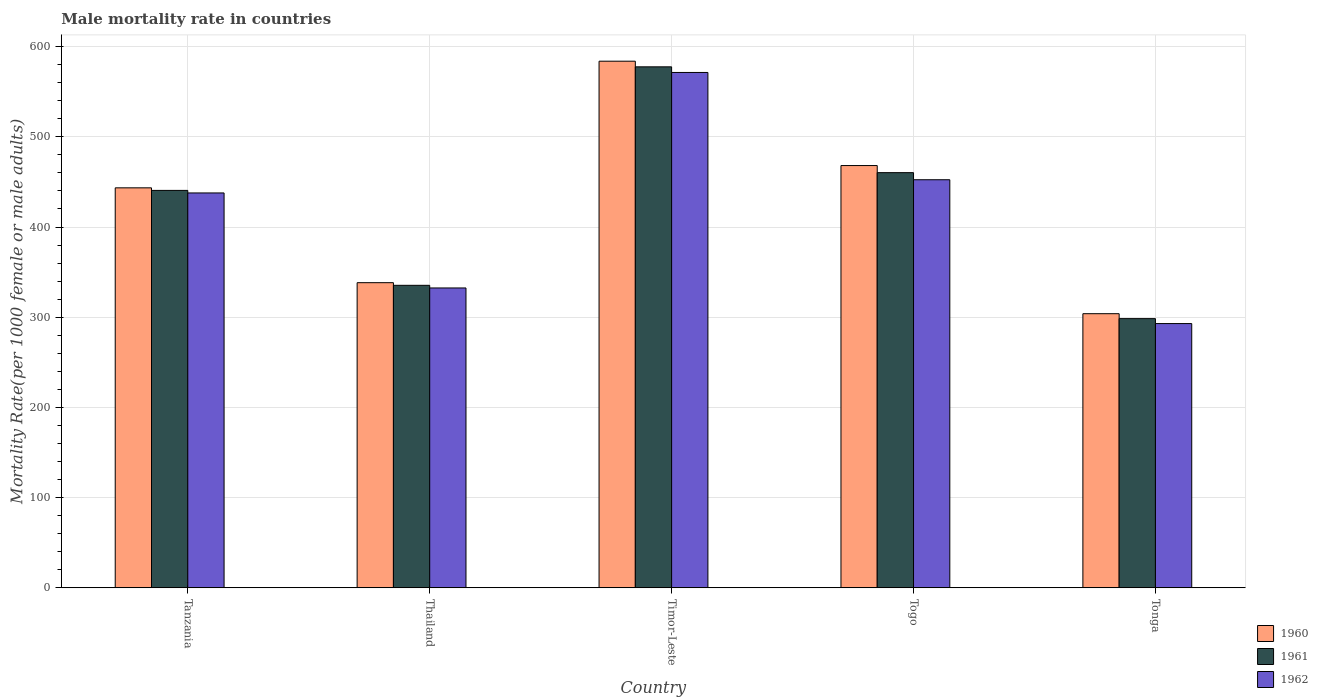How many bars are there on the 1st tick from the left?
Make the answer very short. 3. How many bars are there on the 1st tick from the right?
Your answer should be very brief. 3. What is the label of the 4th group of bars from the left?
Ensure brevity in your answer.  Togo. In how many cases, is the number of bars for a given country not equal to the number of legend labels?
Make the answer very short. 0. What is the male mortality rate in 1962 in Tonga?
Offer a terse response. 292.94. Across all countries, what is the maximum male mortality rate in 1961?
Provide a short and direct response. 577.61. Across all countries, what is the minimum male mortality rate in 1961?
Make the answer very short. 298.41. In which country was the male mortality rate in 1961 maximum?
Your response must be concise. Timor-Leste. In which country was the male mortality rate in 1962 minimum?
Keep it short and to the point. Tonga. What is the total male mortality rate in 1960 in the graph?
Give a very brief answer. 2137.6. What is the difference between the male mortality rate in 1962 in Togo and that in Tonga?
Offer a terse response. 159.48. What is the difference between the male mortality rate in 1962 in Thailand and the male mortality rate in 1960 in Timor-Leste?
Keep it short and to the point. -251.43. What is the average male mortality rate in 1960 per country?
Your answer should be very brief. 427.52. What is the difference between the male mortality rate of/in 1961 and male mortality rate of/in 1962 in Timor-Leste?
Offer a terse response. 6.24. In how many countries, is the male mortality rate in 1960 greater than 380?
Your response must be concise. 3. What is the ratio of the male mortality rate in 1961 in Thailand to that in Togo?
Give a very brief answer. 0.73. Is the male mortality rate in 1961 in Tanzania less than that in Tonga?
Offer a terse response. No. Is the difference between the male mortality rate in 1961 in Tanzania and Tonga greater than the difference between the male mortality rate in 1962 in Tanzania and Tonga?
Give a very brief answer. No. What is the difference between the highest and the second highest male mortality rate in 1961?
Give a very brief answer. -137.01. What is the difference between the highest and the lowest male mortality rate in 1960?
Your response must be concise. 279.97. In how many countries, is the male mortality rate in 1962 greater than the average male mortality rate in 1962 taken over all countries?
Make the answer very short. 3. Is the sum of the male mortality rate in 1961 in Tanzania and Thailand greater than the maximum male mortality rate in 1962 across all countries?
Give a very brief answer. Yes. What does the 1st bar from the right in Thailand represents?
Keep it short and to the point. 1962. Is it the case that in every country, the sum of the male mortality rate in 1962 and male mortality rate in 1961 is greater than the male mortality rate in 1960?
Provide a succinct answer. Yes. How many countries are there in the graph?
Your answer should be very brief. 5. What is the difference between two consecutive major ticks on the Y-axis?
Provide a succinct answer. 100. Are the values on the major ticks of Y-axis written in scientific E-notation?
Ensure brevity in your answer.  No. How are the legend labels stacked?
Your response must be concise. Vertical. What is the title of the graph?
Provide a succinct answer. Male mortality rate in countries. Does "1987" appear as one of the legend labels in the graph?
Make the answer very short. No. What is the label or title of the Y-axis?
Offer a very short reply. Mortality Rate(per 1000 female or male adults). What is the Mortality Rate(per 1000 female or male adults) in 1960 in Tanzania?
Offer a very short reply. 443.44. What is the Mortality Rate(per 1000 female or male adults) of 1961 in Tanzania?
Provide a succinct answer. 440.6. What is the Mortality Rate(per 1000 female or male adults) in 1962 in Tanzania?
Provide a succinct answer. 437.77. What is the Mortality Rate(per 1000 female or male adults) of 1960 in Thailand?
Ensure brevity in your answer.  338.28. What is the Mortality Rate(per 1000 female or male adults) in 1961 in Thailand?
Keep it short and to the point. 335.35. What is the Mortality Rate(per 1000 female or male adults) of 1962 in Thailand?
Give a very brief answer. 332.42. What is the Mortality Rate(per 1000 female or male adults) of 1960 in Timor-Leste?
Provide a succinct answer. 583.85. What is the Mortality Rate(per 1000 female or male adults) of 1961 in Timor-Leste?
Keep it short and to the point. 577.61. What is the Mortality Rate(per 1000 female or male adults) in 1962 in Timor-Leste?
Make the answer very short. 571.37. What is the Mortality Rate(per 1000 female or male adults) in 1960 in Togo?
Your response must be concise. 468.15. What is the Mortality Rate(per 1000 female or male adults) in 1961 in Togo?
Your answer should be compact. 460.29. What is the Mortality Rate(per 1000 female or male adults) of 1962 in Togo?
Your response must be concise. 452.42. What is the Mortality Rate(per 1000 female or male adults) in 1960 in Tonga?
Give a very brief answer. 303.88. What is the Mortality Rate(per 1000 female or male adults) of 1961 in Tonga?
Offer a very short reply. 298.41. What is the Mortality Rate(per 1000 female or male adults) of 1962 in Tonga?
Your answer should be very brief. 292.94. Across all countries, what is the maximum Mortality Rate(per 1000 female or male adults) of 1960?
Keep it short and to the point. 583.85. Across all countries, what is the maximum Mortality Rate(per 1000 female or male adults) in 1961?
Your answer should be compact. 577.61. Across all countries, what is the maximum Mortality Rate(per 1000 female or male adults) of 1962?
Keep it short and to the point. 571.37. Across all countries, what is the minimum Mortality Rate(per 1000 female or male adults) in 1960?
Offer a terse response. 303.88. Across all countries, what is the minimum Mortality Rate(per 1000 female or male adults) in 1961?
Your response must be concise. 298.41. Across all countries, what is the minimum Mortality Rate(per 1000 female or male adults) of 1962?
Make the answer very short. 292.94. What is the total Mortality Rate(per 1000 female or male adults) in 1960 in the graph?
Provide a short and direct response. 2137.6. What is the total Mortality Rate(per 1000 female or male adults) of 1961 in the graph?
Keep it short and to the point. 2112.26. What is the total Mortality Rate(per 1000 female or male adults) in 1962 in the graph?
Your answer should be very brief. 2086.92. What is the difference between the Mortality Rate(per 1000 female or male adults) of 1960 in Tanzania and that in Thailand?
Ensure brevity in your answer.  105.15. What is the difference between the Mortality Rate(per 1000 female or male adults) in 1961 in Tanzania and that in Thailand?
Your answer should be very brief. 105.25. What is the difference between the Mortality Rate(per 1000 female or male adults) in 1962 in Tanzania and that in Thailand?
Keep it short and to the point. 105.34. What is the difference between the Mortality Rate(per 1000 female or male adults) in 1960 in Tanzania and that in Timor-Leste?
Offer a very short reply. -140.41. What is the difference between the Mortality Rate(per 1000 female or male adults) in 1961 in Tanzania and that in Timor-Leste?
Your answer should be compact. -137.01. What is the difference between the Mortality Rate(per 1000 female or male adults) of 1962 in Tanzania and that in Timor-Leste?
Ensure brevity in your answer.  -133.6. What is the difference between the Mortality Rate(per 1000 female or male adults) in 1960 in Tanzania and that in Togo?
Ensure brevity in your answer.  -24.71. What is the difference between the Mortality Rate(per 1000 female or male adults) in 1961 in Tanzania and that in Togo?
Your answer should be compact. -19.68. What is the difference between the Mortality Rate(per 1000 female or male adults) in 1962 in Tanzania and that in Togo?
Your response must be concise. -14.65. What is the difference between the Mortality Rate(per 1000 female or male adults) in 1960 in Tanzania and that in Tonga?
Your answer should be very brief. 139.56. What is the difference between the Mortality Rate(per 1000 female or male adults) in 1961 in Tanzania and that in Tonga?
Keep it short and to the point. 142.19. What is the difference between the Mortality Rate(per 1000 female or male adults) of 1962 in Tanzania and that in Tonga?
Your response must be concise. 144.83. What is the difference between the Mortality Rate(per 1000 female or male adults) of 1960 in Thailand and that in Timor-Leste?
Provide a succinct answer. -245.57. What is the difference between the Mortality Rate(per 1000 female or male adults) in 1961 in Thailand and that in Timor-Leste?
Your response must be concise. -242.26. What is the difference between the Mortality Rate(per 1000 female or male adults) in 1962 in Thailand and that in Timor-Leste?
Offer a very short reply. -238.95. What is the difference between the Mortality Rate(per 1000 female or male adults) in 1960 in Thailand and that in Togo?
Ensure brevity in your answer.  -129.87. What is the difference between the Mortality Rate(per 1000 female or male adults) in 1961 in Thailand and that in Togo?
Provide a short and direct response. -124.93. What is the difference between the Mortality Rate(per 1000 female or male adults) in 1962 in Thailand and that in Togo?
Ensure brevity in your answer.  -120. What is the difference between the Mortality Rate(per 1000 female or male adults) of 1960 in Thailand and that in Tonga?
Your answer should be very brief. 34.4. What is the difference between the Mortality Rate(per 1000 female or male adults) of 1961 in Thailand and that in Tonga?
Provide a succinct answer. 36.94. What is the difference between the Mortality Rate(per 1000 female or male adults) of 1962 in Thailand and that in Tonga?
Give a very brief answer. 39.48. What is the difference between the Mortality Rate(per 1000 female or male adults) of 1960 in Timor-Leste and that in Togo?
Your response must be concise. 115.7. What is the difference between the Mortality Rate(per 1000 female or male adults) in 1961 in Timor-Leste and that in Togo?
Offer a very short reply. 117.33. What is the difference between the Mortality Rate(per 1000 female or male adults) of 1962 in Timor-Leste and that in Togo?
Give a very brief answer. 118.95. What is the difference between the Mortality Rate(per 1000 female or male adults) in 1960 in Timor-Leste and that in Tonga?
Your response must be concise. 279.97. What is the difference between the Mortality Rate(per 1000 female or male adults) of 1961 in Timor-Leste and that in Tonga?
Your answer should be very brief. 279.2. What is the difference between the Mortality Rate(per 1000 female or male adults) in 1962 in Timor-Leste and that in Tonga?
Give a very brief answer. 278.43. What is the difference between the Mortality Rate(per 1000 female or male adults) in 1960 in Togo and that in Tonga?
Your response must be concise. 164.27. What is the difference between the Mortality Rate(per 1000 female or male adults) of 1961 in Togo and that in Tonga?
Your response must be concise. 161.88. What is the difference between the Mortality Rate(per 1000 female or male adults) in 1962 in Togo and that in Tonga?
Your response must be concise. 159.48. What is the difference between the Mortality Rate(per 1000 female or male adults) of 1960 in Tanzania and the Mortality Rate(per 1000 female or male adults) of 1961 in Thailand?
Your response must be concise. 108.08. What is the difference between the Mortality Rate(per 1000 female or male adults) in 1960 in Tanzania and the Mortality Rate(per 1000 female or male adults) in 1962 in Thailand?
Offer a very short reply. 111.01. What is the difference between the Mortality Rate(per 1000 female or male adults) in 1961 in Tanzania and the Mortality Rate(per 1000 female or male adults) in 1962 in Thailand?
Your answer should be very brief. 108.18. What is the difference between the Mortality Rate(per 1000 female or male adults) of 1960 in Tanzania and the Mortality Rate(per 1000 female or male adults) of 1961 in Timor-Leste?
Provide a short and direct response. -134.17. What is the difference between the Mortality Rate(per 1000 female or male adults) in 1960 in Tanzania and the Mortality Rate(per 1000 female or male adults) in 1962 in Timor-Leste?
Ensure brevity in your answer.  -127.93. What is the difference between the Mortality Rate(per 1000 female or male adults) in 1961 in Tanzania and the Mortality Rate(per 1000 female or male adults) in 1962 in Timor-Leste?
Your answer should be compact. -130.77. What is the difference between the Mortality Rate(per 1000 female or male adults) in 1960 in Tanzania and the Mortality Rate(per 1000 female or male adults) in 1961 in Togo?
Make the answer very short. -16.85. What is the difference between the Mortality Rate(per 1000 female or male adults) of 1960 in Tanzania and the Mortality Rate(per 1000 female or male adults) of 1962 in Togo?
Ensure brevity in your answer.  -8.98. What is the difference between the Mortality Rate(per 1000 female or male adults) of 1961 in Tanzania and the Mortality Rate(per 1000 female or male adults) of 1962 in Togo?
Make the answer very short. -11.82. What is the difference between the Mortality Rate(per 1000 female or male adults) of 1960 in Tanzania and the Mortality Rate(per 1000 female or male adults) of 1961 in Tonga?
Give a very brief answer. 145.03. What is the difference between the Mortality Rate(per 1000 female or male adults) of 1960 in Tanzania and the Mortality Rate(per 1000 female or male adults) of 1962 in Tonga?
Ensure brevity in your answer.  150.5. What is the difference between the Mortality Rate(per 1000 female or male adults) in 1961 in Tanzania and the Mortality Rate(per 1000 female or male adults) in 1962 in Tonga?
Offer a terse response. 147.66. What is the difference between the Mortality Rate(per 1000 female or male adults) of 1960 in Thailand and the Mortality Rate(per 1000 female or male adults) of 1961 in Timor-Leste?
Offer a terse response. -239.33. What is the difference between the Mortality Rate(per 1000 female or male adults) in 1960 in Thailand and the Mortality Rate(per 1000 female or male adults) in 1962 in Timor-Leste?
Your answer should be compact. -233.09. What is the difference between the Mortality Rate(per 1000 female or male adults) of 1961 in Thailand and the Mortality Rate(per 1000 female or male adults) of 1962 in Timor-Leste?
Offer a very short reply. -236.02. What is the difference between the Mortality Rate(per 1000 female or male adults) of 1960 in Thailand and the Mortality Rate(per 1000 female or male adults) of 1961 in Togo?
Keep it short and to the point. -122. What is the difference between the Mortality Rate(per 1000 female or male adults) in 1960 in Thailand and the Mortality Rate(per 1000 female or male adults) in 1962 in Togo?
Your response must be concise. -114.14. What is the difference between the Mortality Rate(per 1000 female or male adults) in 1961 in Thailand and the Mortality Rate(per 1000 female or male adults) in 1962 in Togo?
Offer a very short reply. -117.06. What is the difference between the Mortality Rate(per 1000 female or male adults) of 1960 in Thailand and the Mortality Rate(per 1000 female or male adults) of 1961 in Tonga?
Keep it short and to the point. 39.87. What is the difference between the Mortality Rate(per 1000 female or male adults) in 1960 in Thailand and the Mortality Rate(per 1000 female or male adults) in 1962 in Tonga?
Make the answer very short. 45.34. What is the difference between the Mortality Rate(per 1000 female or male adults) in 1961 in Thailand and the Mortality Rate(per 1000 female or male adults) in 1962 in Tonga?
Make the answer very short. 42.41. What is the difference between the Mortality Rate(per 1000 female or male adults) of 1960 in Timor-Leste and the Mortality Rate(per 1000 female or male adults) of 1961 in Togo?
Ensure brevity in your answer.  123.56. What is the difference between the Mortality Rate(per 1000 female or male adults) of 1960 in Timor-Leste and the Mortality Rate(per 1000 female or male adults) of 1962 in Togo?
Keep it short and to the point. 131.43. What is the difference between the Mortality Rate(per 1000 female or male adults) in 1961 in Timor-Leste and the Mortality Rate(per 1000 female or male adults) in 1962 in Togo?
Offer a very short reply. 125.19. What is the difference between the Mortality Rate(per 1000 female or male adults) in 1960 in Timor-Leste and the Mortality Rate(per 1000 female or male adults) in 1961 in Tonga?
Your response must be concise. 285.44. What is the difference between the Mortality Rate(per 1000 female or male adults) of 1960 in Timor-Leste and the Mortality Rate(per 1000 female or male adults) of 1962 in Tonga?
Your answer should be compact. 290.91. What is the difference between the Mortality Rate(per 1000 female or male adults) in 1961 in Timor-Leste and the Mortality Rate(per 1000 female or male adults) in 1962 in Tonga?
Keep it short and to the point. 284.67. What is the difference between the Mortality Rate(per 1000 female or male adults) of 1960 in Togo and the Mortality Rate(per 1000 female or male adults) of 1961 in Tonga?
Keep it short and to the point. 169.74. What is the difference between the Mortality Rate(per 1000 female or male adults) in 1960 in Togo and the Mortality Rate(per 1000 female or male adults) in 1962 in Tonga?
Give a very brief answer. 175.21. What is the difference between the Mortality Rate(per 1000 female or male adults) of 1961 in Togo and the Mortality Rate(per 1000 female or male adults) of 1962 in Tonga?
Make the answer very short. 167.35. What is the average Mortality Rate(per 1000 female or male adults) in 1960 per country?
Ensure brevity in your answer.  427.52. What is the average Mortality Rate(per 1000 female or male adults) of 1961 per country?
Provide a succinct answer. 422.45. What is the average Mortality Rate(per 1000 female or male adults) of 1962 per country?
Provide a succinct answer. 417.38. What is the difference between the Mortality Rate(per 1000 female or male adults) in 1960 and Mortality Rate(per 1000 female or male adults) in 1961 in Tanzania?
Ensure brevity in your answer.  2.83. What is the difference between the Mortality Rate(per 1000 female or male adults) in 1960 and Mortality Rate(per 1000 female or male adults) in 1962 in Tanzania?
Give a very brief answer. 5.67. What is the difference between the Mortality Rate(per 1000 female or male adults) of 1961 and Mortality Rate(per 1000 female or male adults) of 1962 in Tanzania?
Offer a very short reply. 2.83. What is the difference between the Mortality Rate(per 1000 female or male adults) of 1960 and Mortality Rate(per 1000 female or male adults) of 1961 in Thailand?
Provide a succinct answer. 2.93. What is the difference between the Mortality Rate(per 1000 female or male adults) in 1960 and Mortality Rate(per 1000 female or male adults) in 1962 in Thailand?
Your answer should be very brief. 5.86. What is the difference between the Mortality Rate(per 1000 female or male adults) of 1961 and Mortality Rate(per 1000 female or male adults) of 1962 in Thailand?
Provide a succinct answer. 2.93. What is the difference between the Mortality Rate(per 1000 female or male adults) of 1960 and Mortality Rate(per 1000 female or male adults) of 1961 in Timor-Leste?
Make the answer very short. 6.24. What is the difference between the Mortality Rate(per 1000 female or male adults) in 1960 and Mortality Rate(per 1000 female or male adults) in 1962 in Timor-Leste?
Your answer should be very brief. 12.48. What is the difference between the Mortality Rate(per 1000 female or male adults) in 1961 and Mortality Rate(per 1000 female or male adults) in 1962 in Timor-Leste?
Your response must be concise. 6.24. What is the difference between the Mortality Rate(per 1000 female or male adults) in 1960 and Mortality Rate(per 1000 female or male adults) in 1961 in Togo?
Keep it short and to the point. 7.87. What is the difference between the Mortality Rate(per 1000 female or male adults) of 1960 and Mortality Rate(per 1000 female or male adults) of 1962 in Togo?
Keep it short and to the point. 15.73. What is the difference between the Mortality Rate(per 1000 female or male adults) of 1961 and Mortality Rate(per 1000 female or male adults) of 1962 in Togo?
Give a very brief answer. 7.87. What is the difference between the Mortality Rate(per 1000 female or male adults) of 1960 and Mortality Rate(per 1000 female or male adults) of 1961 in Tonga?
Your response must be concise. 5.47. What is the difference between the Mortality Rate(per 1000 female or male adults) in 1960 and Mortality Rate(per 1000 female or male adults) in 1962 in Tonga?
Make the answer very short. 10.94. What is the difference between the Mortality Rate(per 1000 female or male adults) of 1961 and Mortality Rate(per 1000 female or male adults) of 1962 in Tonga?
Give a very brief answer. 5.47. What is the ratio of the Mortality Rate(per 1000 female or male adults) of 1960 in Tanzania to that in Thailand?
Your response must be concise. 1.31. What is the ratio of the Mortality Rate(per 1000 female or male adults) in 1961 in Tanzania to that in Thailand?
Your response must be concise. 1.31. What is the ratio of the Mortality Rate(per 1000 female or male adults) in 1962 in Tanzania to that in Thailand?
Your answer should be compact. 1.32. What is the ratio of the Mortality Rate(per 1000 female or male adults) in 1960 in Tanzania to that in Timor-Leste?
Provide a short and direct response. 0.76. What is the ratio of the Mortality Rate(per 1000 female or male adults) of 1961 in Tanzania to that in Timor-Leste?
Offer a very short reply. 0.76. What is the ratio of the Mortality Rate(per 1000 female or male adults) of 1962 in Tanzania to that in Timor-Leste?
Provide a short and direct response. 0.77. What is the ratio of the Mortality Rate(per 1000 female or male adults) in 1960 in Tanzania to that in Togo?
Offer a very short reply. 0.95. What is the ratio of the Mortality Rate(per 1000 female or male adults) of 1961 in Tanzania to that in Togo?
Your answer should be compact. 0.96. What is the ratio of the Mortality Rate(per 1000 female or male adults) of 1962 in Tanzania to that in Togo?
Offer a terse response. 0.97. What is the ratio of the Mortality Rate(per 1000 female or male adults) of 1960 in Tanzania to that in Tonga?
Your answer should be compact. 1.46. What is the ratio of the Mortality Rate(per 1000 female or male adults) in 1961 in Tanzania to that in Tonga?
Give a very brief answer. 1.48. What is the ratio of the Mortality Rate(per 1000 female or male adults) of 1962 in Tanzania to that in Tonga?
Give a very brief answer. 1.49. What is the ratio of the Mortality Rate(per 1000 female or male adults) in 1960 in Thailand to that in Timor-Leste?
Offer a terse response. 0.58. What is the ratio of the Mortality Rate(per 1000 female or male adults) of 1961 in Thailand to that in Timor-Leste?
Your response must be concise. 0.58. What is the ratio of the Mortality Rate(per 1000 female or male adults) in 1962 in Thailand to that in Timor-Leste?
Your response must be concise. 0.58. What is the ratio of the Mortality Rate(per 1000 female or male adults) of 1960 in Thailand to that in Togo?
Your response must be concise. 0.72. What is the ratio of the Mortality Rate(per 1000 female or male adults) in 1961 in Thailand to that in Togo?
Keep it short and to the point. 0.73. What is the ratio of the Mortality Rate(per 1000 female or male adults) of 1962 in Thailand to that in Togo?
Your answer should be compact. 0.73. What is the ratio of the Mortality Rate(per 1000 female or male adults) in 1960 in Thailand to that in Tonga?
Provide a succinct answer. 1.11. What is the ratio of the Mortality Rate(per 1000 female or male adults) in 1961 in Thailand to that in Tonga?
Offer a terse response. 1.12. What is the ratio of the Mortality Rate(per 1000 female or male adults) in 1962 in Thailand to that in Tonga?
Provide a succinct answer. 1.13. What is the ratio of the Mortality Rate(per 1000 female or male adults) in 1960 in Timor-Leste to that in Togo?
Your response must be concise. 1.25. What is the ratio of the Mortality Rate(per 1000 female or male adults) of 1961 in Timor-Leste to that in Togo?
Provide a succinct answer. 1.25. What is the ratio of the Mortality Rate(per 1000 female or male adults) of 1962 in Timor-Leste to that in Togo?
Ensure brevity in your answer.  1.26. What is the ratio of the Mortality Rate(per 1000 female or male adults) of 1960 in Timor-Leste to that in Tonga?
Your answer should be compact. 1.92. What is the ratio of the Mortality Rate(per 1000 female or male adults) of 1961 in Timor-Leste to that in Tonga?
Provide a succinct answer. 1.94. What is the ratio of the Mortality Rate(per 1000 female or male adults) of 1962 in Timor-Leste to that in Tonga?
Provide a succinct answer. 1.95. What is the ratio of the Mortality Rate(per 1000 female or male adults) of 1960 in Togo to that in Tonga?
Provide a succinct answer. 1.54. What is the ratio of the Mortality Rate(per 1000 female or male adults) of 1961 in Togo to that in Tonga?
Offer a terse response. 1.54. What is the ratio of the Mortality Rate(per 1000 female or male adults) of 1962 in Togo to that in Tonga?
Your response must be concise. 1.54. What is the difference between the highest and the second highest Mortality Rate(per 1000 female or male adults) of 1960?
Keep it short and to the point. 115.7. What is the difference between the highest and the second highest Mortality Rate(per 1000 female or male adults) of 1961?
Offer a terse response. 117.33. What is the difference between the highest and the second highest Mortality Rate(per 1000 female or male adults) in 1962?
Your answer should be very brief. 118.95. What is the difference between the highest and the lowest Mortality Rate(per 1000 female or male adults) in 1960?
Offer a terse response. 279.97. What is the difference between the highest and the lowest Mortality Rate(per 1000 female or male adults) in 1961?
Your answer should be compact. 279.2. What is the difference between the highest and the lowest Mortality Rate(per 1000 female or male adults) in 1962?
Provide a succinct answer. 278.43. 